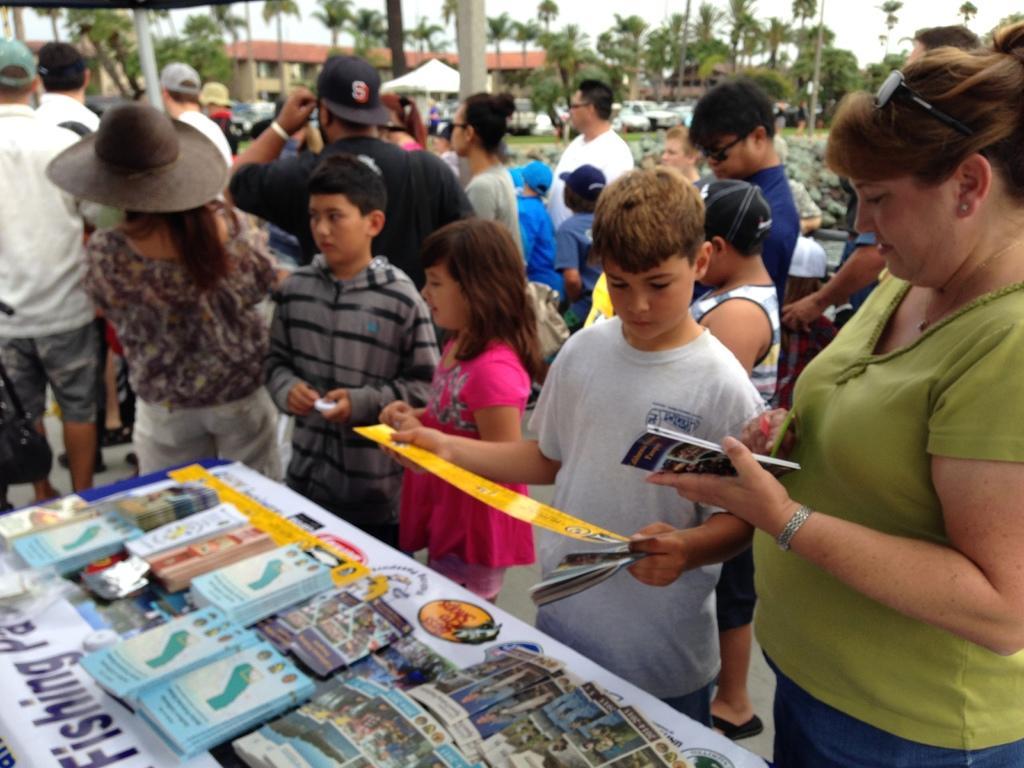How would you summarize this image in a sentence or two? In this image there are many people. At the bottom of the image there is a stall with books on it. At the center of the image there is a girl wearing pink color dress. At the background of the image there are many trees. 